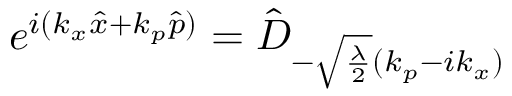<formula> <loc_0><loc_0><loc_500><loc_500>e ^ { i ( k _ { x } \hat { x } + k _ { p } \hat { p } ) } = \hat { D } _ { - \sqrt { \frac { \lambda } { 2 } } ( k _ { p } - i k _ { x } ) }</formula> 